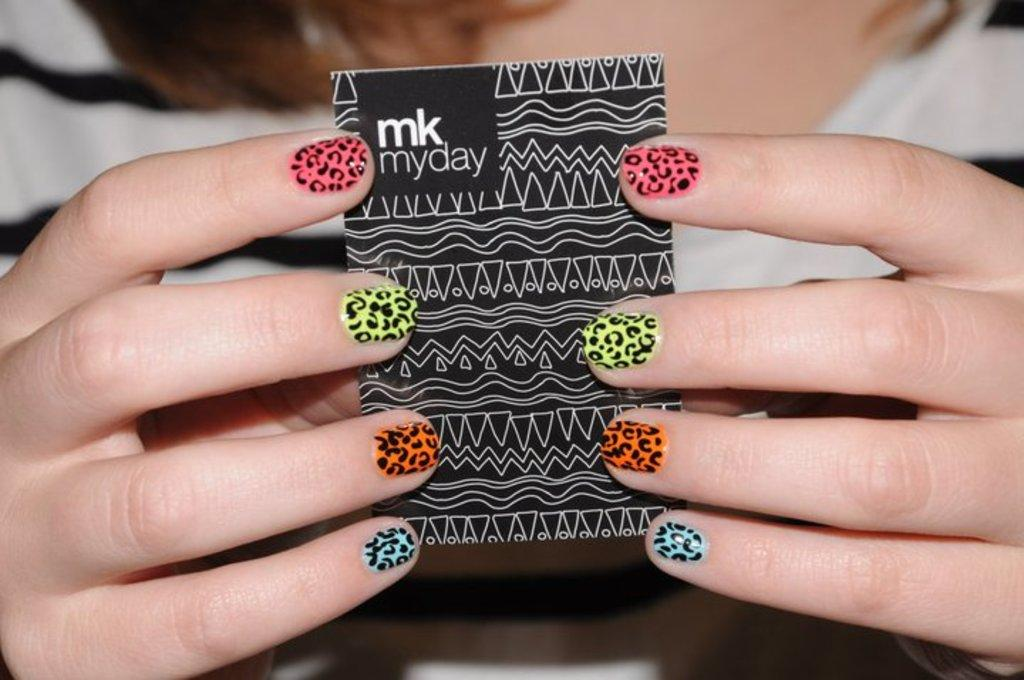Who is present in the image? There is a person in the image. What is the person holding in the image? The person is holding a card in the image. What is depicted on the card? The card has hands depicted on it. What can be seen on the person's nails in the image? Nail polish is visible on the nails in the image. What type of snails can be seen crawling on the person's nails in the image? There are no snails present in the image; only nail polish is visible on the nails. 